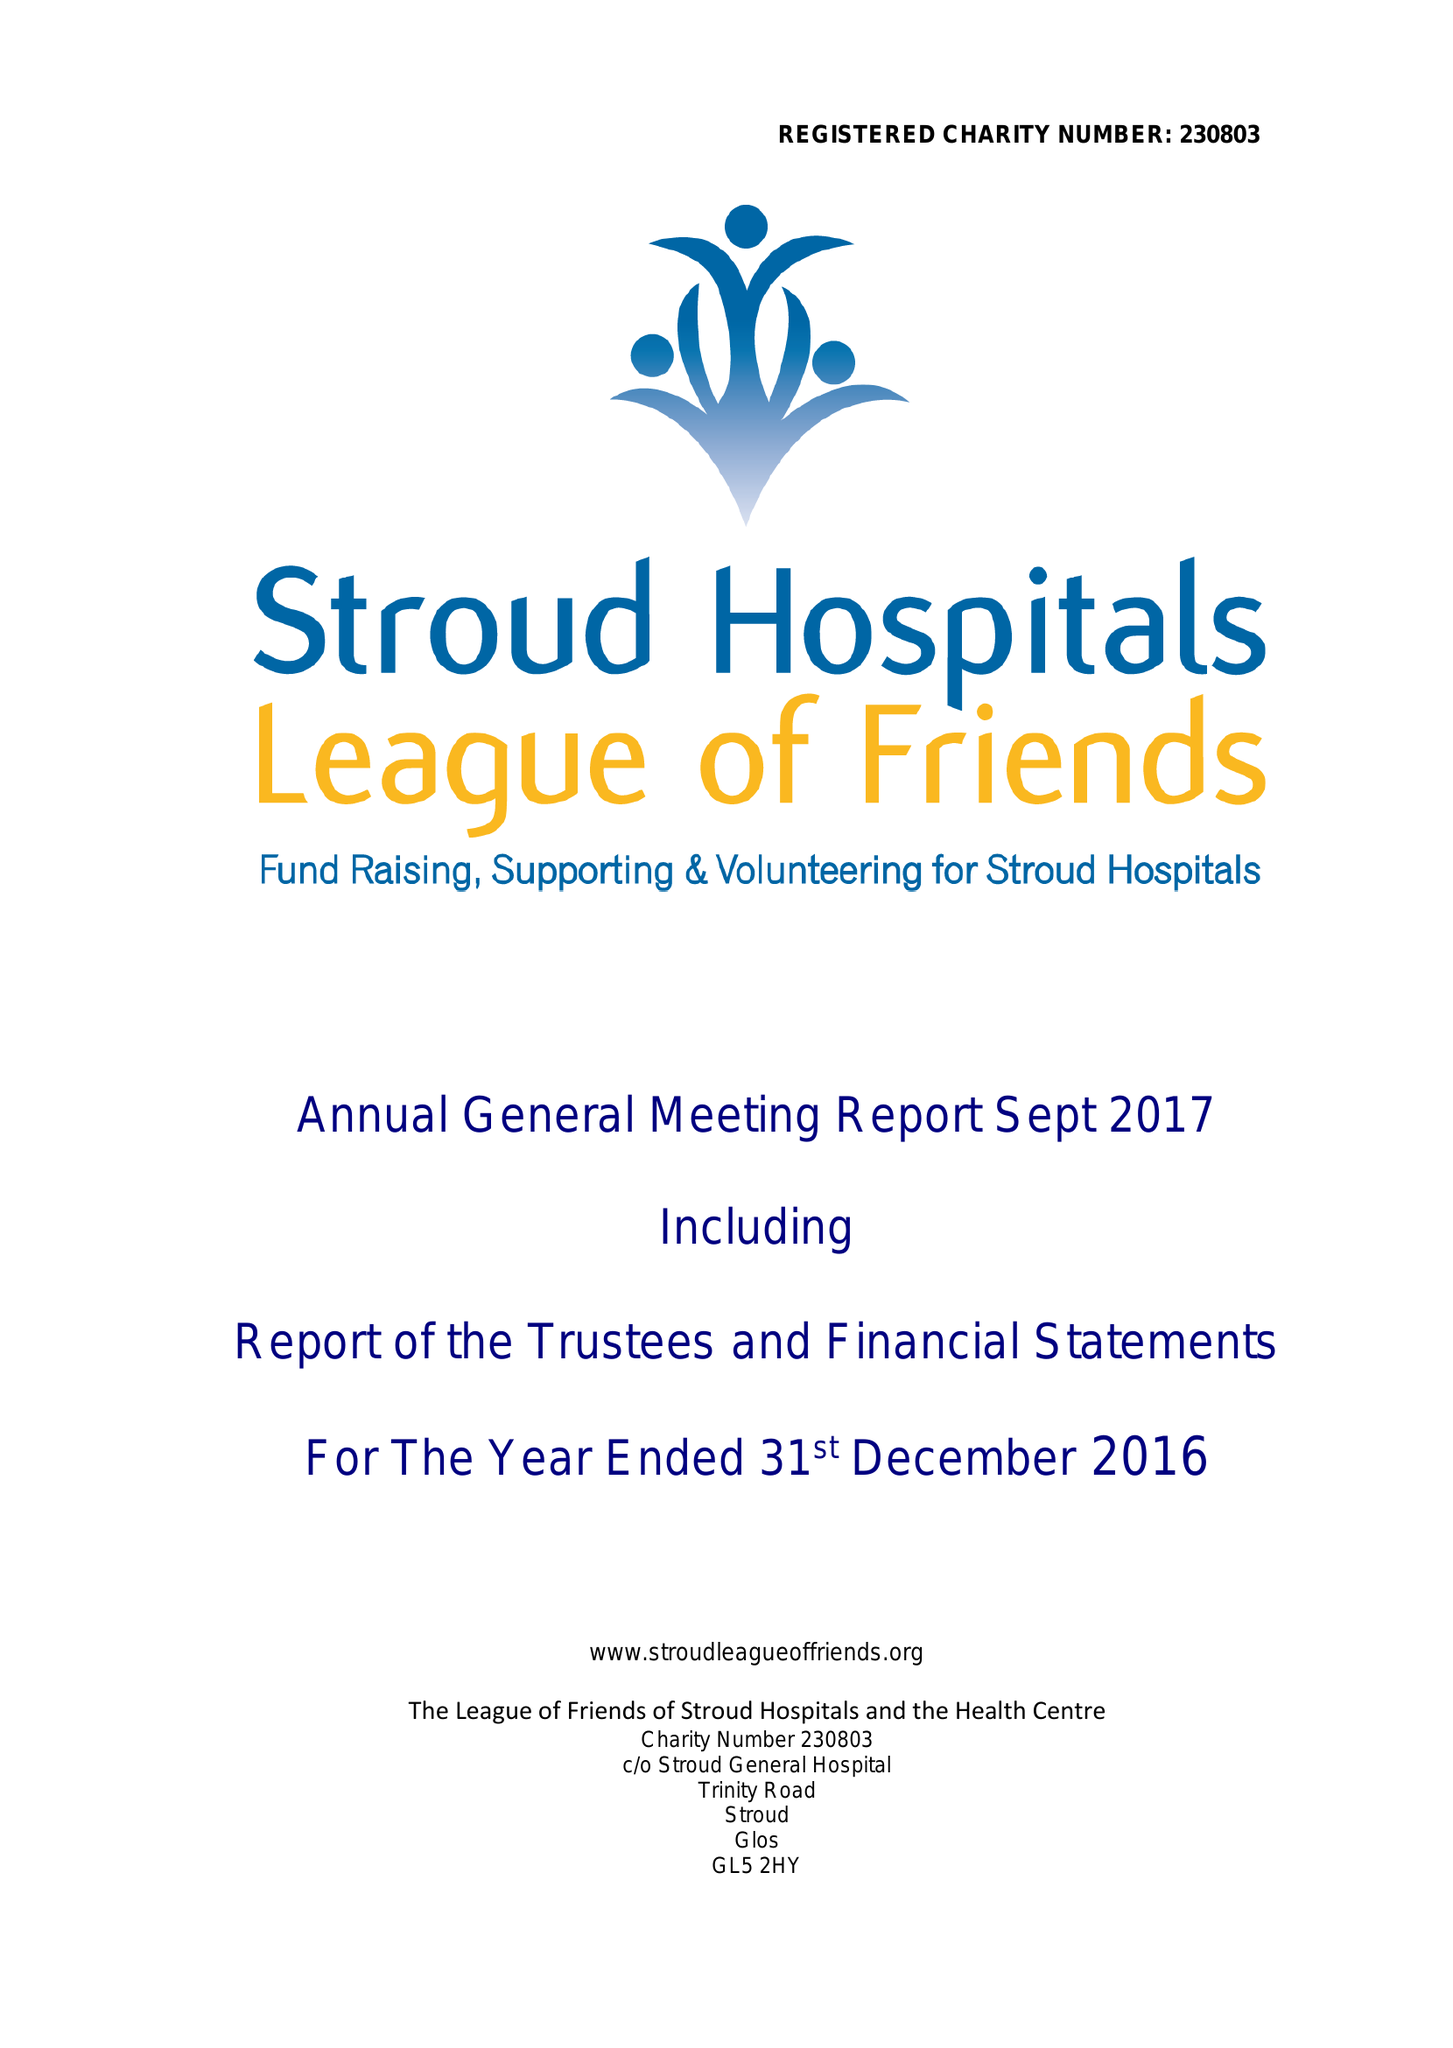What is the value for the charity_name?
Answer the question using a single word or phrase. The League Of Friends Of Stroud Hospitals and The Health Centre 